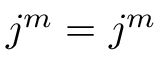Convert formula to latex. <formula><loc_0><loc_0><loc_500><loc_500>\ v _ { j } ^ { m } = \ u _ { j } ^ { m }</formula> 